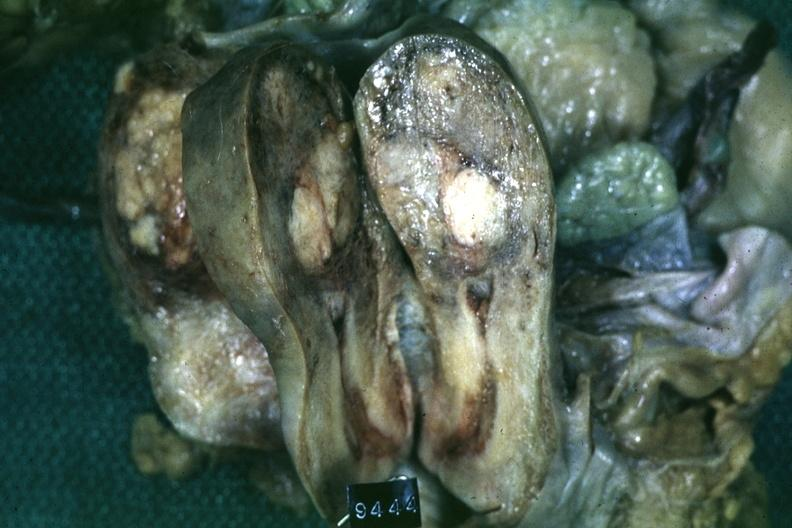where does this belong to?
Answer the question using a single word or phrase. Female reproductive system 